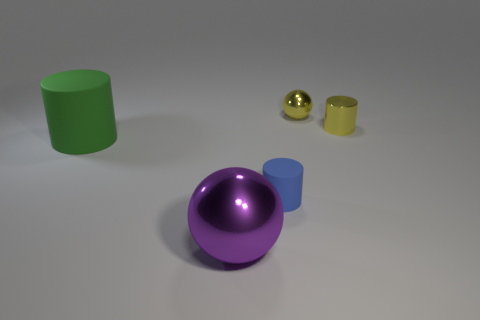What is the color of the cylinder that is made of the same material as the yellow sphere?
Give a very brief answer. Yellow. The shiny object that is the same shape as the large rubber thing is what color?
Offer a terse response. Yellow. Do the green rubber cylinder and the yellow metallic ball have the same size?
Your response must be concise. No. Are there the same number of purple metal things right of the small sphere and small matte things that are right of the tiny yellow cylinder?
Your answer should be compact. Yes. The yellow object that is the same shape as the large purple metal thing is what size?
Provide a short and direct response. Small. Is the big purple metallic thing the same shape as the big green thing?
Keep it short and to the point. No. Is there any other thing that is the same shape as the big metal thing?
Your answer should be compact. Yes. Do the small cylinder behind the large green rubber cylinder and the large ball have the same material?
Make the answer very short. Yes. What is the shape of the thing that is right of the large shiny thing and in front of the metal cylinder?
Keep it short and to the point. Cylinder. Are there any tiny rubber objects behind the small metallic object in front of the tiny yellow shiny sphere?
Offer a very short reply. No. 